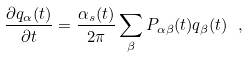Convert formula to latex. <formula><loc_0><loc_0><loc_500><loc_500>\frac { \partial q _ { \alpha } ( t ) } { \partial t } = \frac { \alpha _ { s } ( t ) } { 2 \pi } \sum _ { \beta } P _ { \alpha \beta } ( t ) q _ { \beta } ( t ) \ ,</formula> 